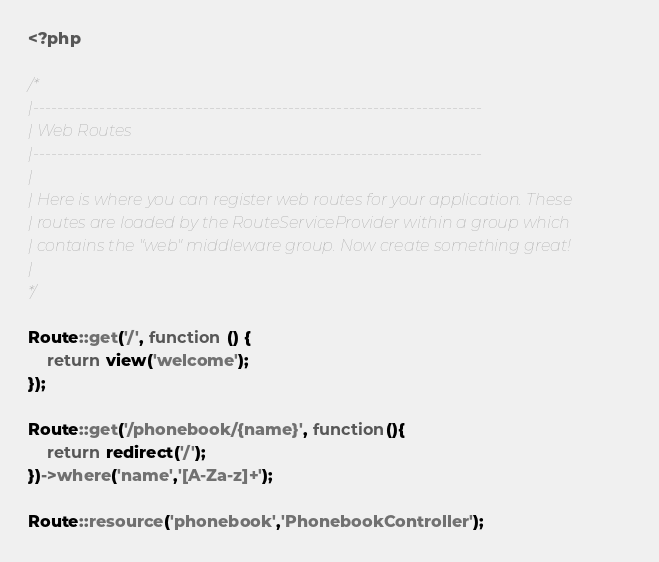Convert code to text. <code><loc_0><loc_0><loc_500><loc_500><_PHP_><?php

/*
|--------------------------------------------------------------------------
| Web Routes
|--------------------------------------------------------------------------
|
| Here is where you can register web routes for your application. These
| routes are loaded by the RouteServiceProvider within a group which
| contains the "web" middleware group. Now create something great!
|
*/

Route::get('/', function () {
    return view('welcome');
});

Route::get('/phonebook/{name}', function(){
    return redirect('/');
})->where('name','[A-Za-z]+');

Route::resource('phonebook','PhonebookController');</code> 